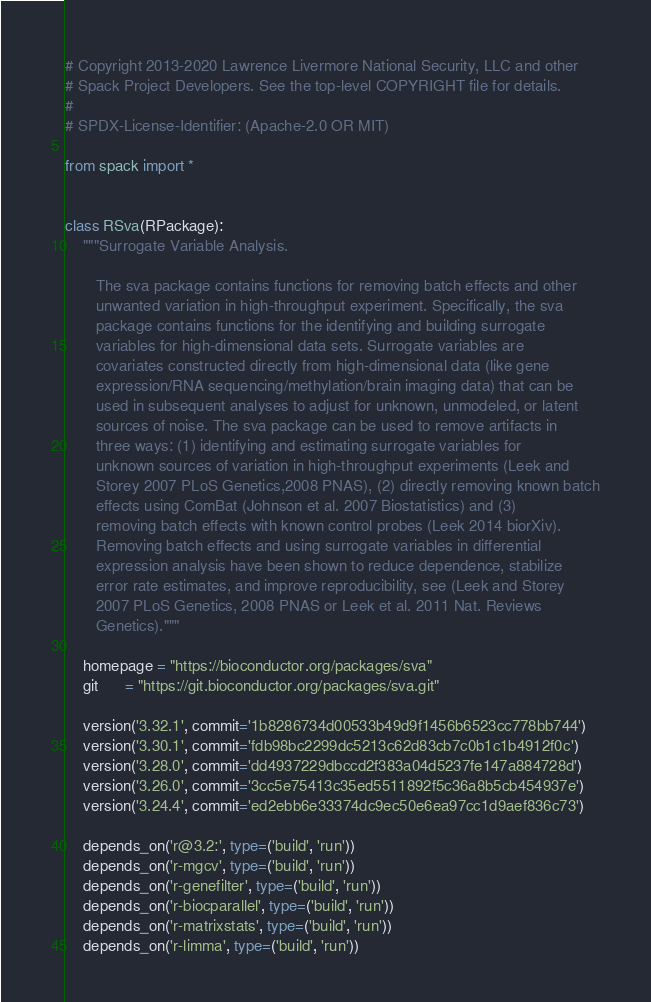<code> <loc_0><loc_0><loc_500><loc_500><_Python_># Copyright 2013-2020 Lawrence Livermore National Security, LLC and other
# Spack Project Developers. See the top-level COPYRIGHT file for details.
#
# SPDX-License-Identifier: (Apache-2.0 OR MIT)

from spack import *


class RSva(RPackage):
    """Surrogate Variable Analysis.

       The sva package contains functions for removing batch effects and other
       unwanted variation in high-throughput experiment. Specifically, the sva
       package contains functions for the identifying and building surrogate
       variables for high-dimensional data sets. Surrogate variables are
       covariates constructed directly from high-dimensional data (like gene
       expression/RNA sequencing/methylation/brain imaging data) that can be
       used in subsequent analyses to adjust for unknown, unmodeled, or latent
       sources of noise. The sva package can be used to remove artifacts in
       three ways: (1) identifying and estimating surrogate variables for
       unknown sources of variation in high-throughput experiments (Leek and
       Storey 2007 PLoS Genetics,2008 PNAS), (2) directly removing known batch
       effects using ComBat (Johnson et al. 2007 Biostatistics) and (3)
       removing batch effects with known control probes (Leek 2014 biorXiv).
       Removing batch effects and using surrogate variables in differential
       expression analysis have been shown to reduce dependence, stabilize
       error rate estimates, and improve reproducibility, see (Leek and Storey
       2007 PLoS Genetics, 2008 PNAS or Leek et al. 2011 Nat. Reviews
       Genetics)."""

    homepage = "https://bioconductor.org/packages/sva"
    git      = "https://git.bioconductor.org/packages/sva.git"

    version('3.32.1', commit='1b8286734d00533b49d9f1456b6523cc778bb744')
    version('3.30.1', commit='fdb98bc2299dc5213c62d83cb7c0b1c1b4912f0c')
    version('3.28.0', commit='dd4937229dbccd2f383a04d5237fe147a884728d')
    version('3.26.0', commit='3cc5e75413c35ed5511892f5c36a8b5cb454937e')
    version('3.24.4', commit='ed2ebb6e33374dc9ec50e6ea97cc1d9aef836c73')

    depends_on('r@3.2:', type=('build', 'run'))
    depends_on('r-mgcv', type=('build', 'run'))
    depends_on('r-genefilter', type=('build', 'run'))
    depends_on('r-biocparallel', type=('build', 'run'))
    depends_on('r-matrixstats', type=('build', 'run'))
    depends_on('r-limma', type=('build', 'run'))
</code> 